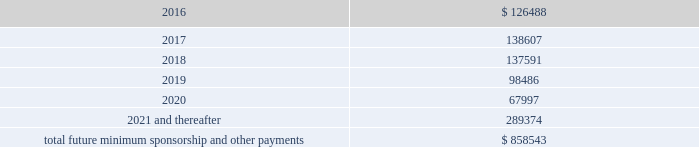Included in selling , general and administrative expense was rent expense of $ 83.0 million , $ 59.0 million and $ 41.8 million for the years ended december 31 , 2015 , 2014 and 2013 , respectively , under non-cancelable operating lease agreements .
Included in these amounts was contingent rent expense of $ 11.0 million , $ 11.0 million and $ 7.8 million for the years ended december 31 , 2015 , 2014 and 2013 , respectively .
Sports marketing and other commitments within the normal course of business , the company enters into contractual commitments in order to promote the company 2019s brand and products .
These commitments include sponsorship agreements with teams and athletes on the collegiate and professional levels , official supplier agreements , athletic event sponsorships and other marketing commitments .
The following is a schedule of the company 2019s future minimum payments under its sponsorship and other marketing agreements as of december 31 , 2015 , as well as significant sponsorship and other marketing agreements entered into during the period after december 31 , 2015 through the date of this report : ( in thousands ) .
The amounts listed above are the minimum compensation obligations and guaranteed royalty fees required to be paid under the company 2019s sponsorship and other marketing agreements .
The amounts listed above do not include additional performance incentives and product supply obligations provided under certain agreements .
It is not possible to determine how much the company will spend on product supply obligations on an annual basis as contracts generally do not stipulate specific cash amounts to be spent on products .
The amount of product provided to the sponsorships depends on many factors including general playing conditions , the number of sporting events in which they participate and the company 2019s decisions regarding product and marketing initiatives .
In addition , the costs to design , develop , source and purchase the products furnished to the endorsers are incurred over a period of time and are not necessarily tracked separately from similar costs incurred for products sold to customers .
In connection with various contracts and agreements , the company has agreed to indemnify counterparties against certain third party claims relating to the infringement of intellectual property rights and other items .
Generally , such indemnification obligations do not apply in situations in which the counterparties are grossly negligent , engage in willful misconduct , or act in bad faith .
Based on the company 2019s historical experience and the estimated probability of future loss , the company has determined that the fair value of such indemnifications is not material to its consolidated financial position or results of operations .
From time to time , the company is involved in litigation and other proceedings , including matters related to commercial and intellectual property disputes , as well as trade , regulatory and other claims related to its business .
The company believes that all current proceedings are routine in nature and incidental to the conduct of its business , and that the ultimate resolution of any such proceedings will not have a material adverse effect on its consolidated financial position , results of operations or cash flows .
Following the company 2019s announcement of the creation of a new class of common stock , referred to as the class c common stock , par value $ 0.0003 1/3 per share , four purported class action lawsuits were brought .
Based on the schedule of the company 2019s future minimum payments as of december 312015 what was the percent of the amount due in 2016 to the total? 
Computations: (126488 / 858543)
Answer: 0.14733. 